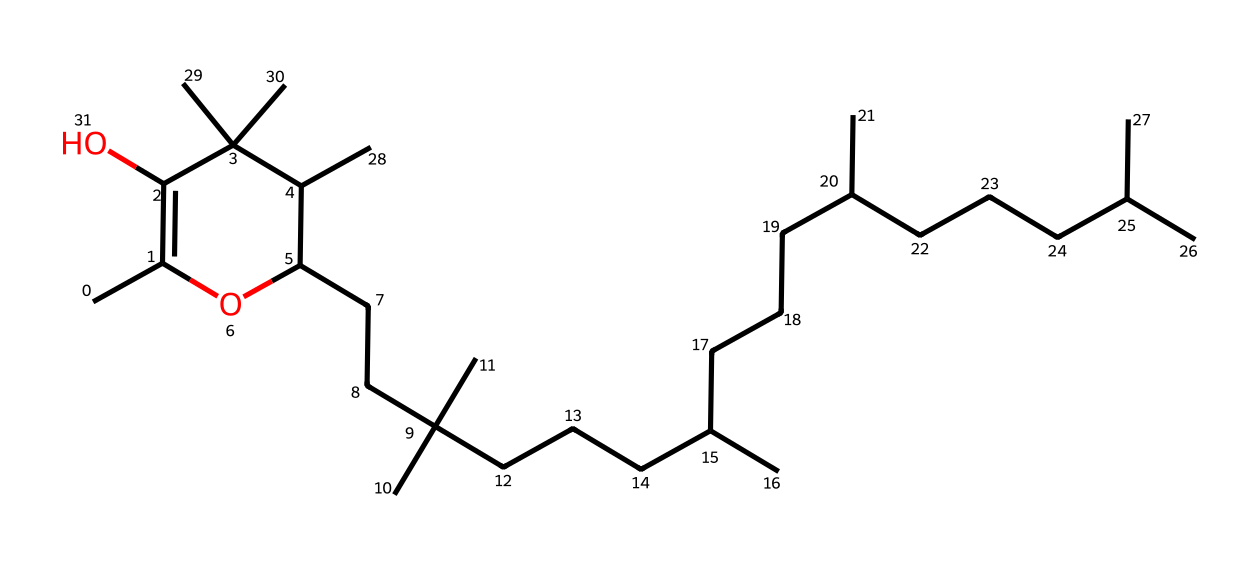What type of vitamin is represented by this chemical structure? The chemical structure corresponds to vitamin E, which is known for its role as an antioxidant.
Answer: vitamin E How many carbon atoms are present in the molecular structure? By analyzing the SMILES representation, we can count the number of 'C' characters, yielding a total of 36 carbon atoms.
Answer: 36 What feature of this structure indicates it has antioxidant properties? The presence of multiple hydroxyl (-OH) groups, located on the rings of the structure, indicates that it can donate hydrogen atoms, which gives it antioxidant properties.
Answer: hydroxyl groups How many hydroxyl groups are present in this molecule? The SMILES shows two instances of '-OH' attached to the carbon chains, confirming there are two hydroxyl groups involved in the structure.
Answer: 2 What is the main skin health benefit of vitamin E derived from its structure? Vitamin E's structure allows it to stabilize cell membranes, assisting in skin hydration and protection from oxidative stress, promoting healthier skin for athletes.
Answer: skin hydration What type of bond predominates in the carbon chains of this vitamin E structure? The long carbon chains primarily consist of single bonds (sigma bonds), characteristic of saturated compounds common in vitamin structures like vitamin E.
Answer: single bonds 